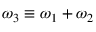Convert formula to latex. <formula><loc_0><loc_0><loc_500><loc_500>\omega _ { 3 } \equiv \omega _ { 1 } + \omega _ { 2 }</formula> 